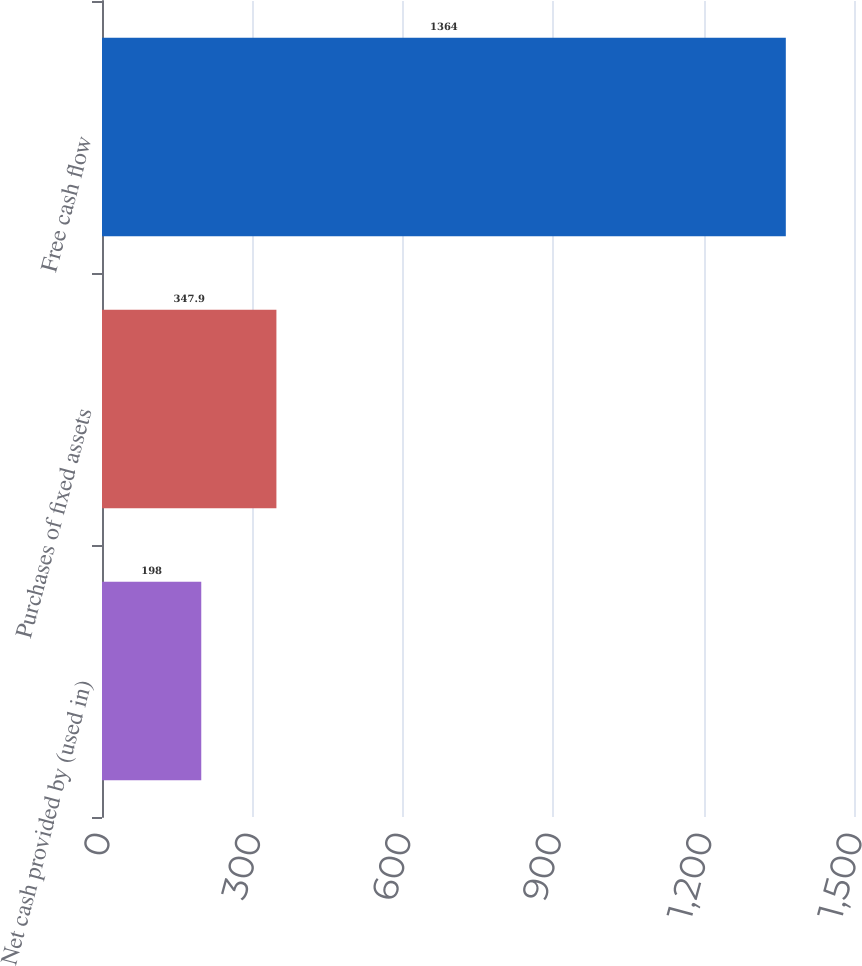Convert chart to OTSL. <chart><loc_0><loc_0><loc_500><loc_500><bar_chart><fcel>Net cash provided by (used in)<fcel>Purchases of fixed assets<fcel>Free cash flow<nl><fcel>198<fcel>347.9<fcel>1364<nl></chart> 